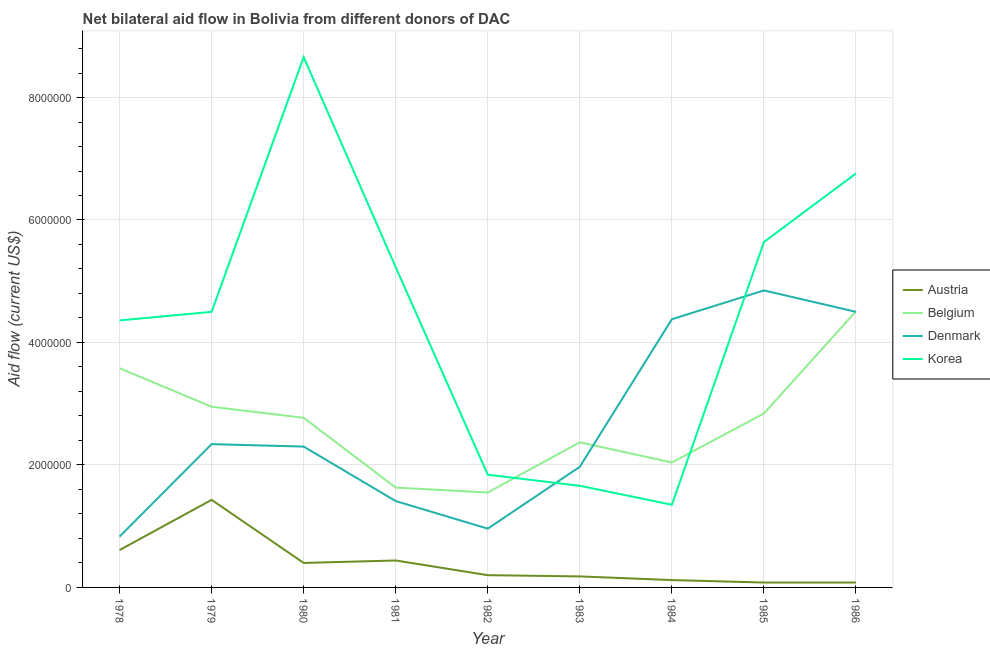Does the line corresponding to amount of aid given by austria intersect with the line corresponding to amount of aid given by korea?
Provide a succinct answer. No. What is the amount of aid given by austria in 1981?
Offer a very short reply. 4.40e+05. Across all years, what is the maximum amount of aid given by korea?
Give a very brief answer. 8.66e+06. Across all years, what is the minimum amount of aid given by austria?
Provide a succinct answer. 8.00e+04. In which year was the amount of aid given by belgium minimum?
Offer a terse response. 1982. What is the total amount of aid given by austria in the graph?
Your response must be concise. 3.54e+06. What is the difference between the amount of aid given by korea in 1979 and that in 1982?
Make the answer very short. 2.66e+06. What is the difference between the amount of aid given by austria in 1984 and the amount of aid given by denmark in 1986?
Provide a short and direct response. -4.38e+06. What is the average amount of aid given by denmark per year?
Make the answer very short. 2.62e+06. In the year 1983, what is the difference between the amount of aid given by denmark and amount of aid given by austria?
Give a very brief answer. 1.79e+06. What is the ratio of the amount of aid given by austria in 1980 to that in 1984?
Your answer should be compact. 3.33. Is the amount of aid given by denmark in 1980 less than that in 1982?
Offer a very short reply. No. Is the difference between the amount of aid given by belgium in 1979 and 1981 greater than the difference between the amount of aid given by austria in 1979 and 1981?
Provide a short and direct response. Yes. What is the difference between the highest and the second highest amount of aid given by korea?
Offer a terse response. 1.90e+06. What is the difference between the highest and the lowest amount of aid given by korea?
Provide a short and direct response. 7.31e+06. In how many years, is the amount of aid given by austria greater than the average amount of aid given by austria taken over all years?
Offer a very short reply. 4. Is the sum of the amount of aid given by belgium in 1983 and 1986 greater than the maximum amount of aid given by denmark across all years?
Your response must be concise. Yes. Is it the case that in every year, the sum of the amount of aid given by belgium and amount of aid given by austria is greater than the sum of amount of aid given by korea and amount of aid given by denmark?
Your response must be concise. No. Is it the case that in every year, the sum of the amount of aid given by austria and amount of aid given by belgium is greater than the amount of aid given by denmark?
Provide a short and direct response. No. Does the amount of aid given by belgium monotonically increase over the years?
Give a very brief answer. No. Is the amount of aid given by belgium strictly greater than the amount of aid given by denmark over the years?
Offer a terse response. No. How many lines are there?
Offer a terse response. 4. How many years are there in the graph?
Provide a short and direct response. 9. Does the graph contain any zero values?
Your answer should be very brief. No. Does the graph contain grids?
Your answer should be compact. Yes. How are the legend labels stacked?
Your answer should be compact. Vertical. What is the title of the graph?
Provide a short and direct response. Net bilateral aid flow in Bolivia from different donors of DAC. What is the label or title of the Y-axis?
Give a very brief answer. Aid flow (current US$). What is the Aid flow (current US$) in Austria in 1978?
Make the answer very short. 6.10e+05. What is the Aid flow (current US$) of Belgium in 1978?
Offer a very short reply. 3.58e+06. What is the Aid flow (current US$) in Denmark in 1978?
Keep it short and to the point. 8.30e+05. What is the Aid flow (current US$) of Korea in 1978?
Keep it short and to the point. 4.36e+06. What is the Aid flow (current US$) of Austria in 1979?
Your response must be concise. 1.43e+06. What is the Aid flow (current US$) in Belgium in 1979?
Provide a short and direct response. 2.95e+06. What is the Aid flow (current US$) in Denmark in 1979?
Your answer should be compact. 2.34e+06. What is the Aid flow (current US$) in Korea in 1979?
Give a very brief answer. 4.50e+06. What is the Aid flow (current US$) in Austria in 1980?
Your answer should be compact. 4.00e+05. What is the Aid flow (current US$) in Belgium in 1980?
Keep it short and to the point. 2.77e+06. What is the Aid flow (current US$) of Denmark in 1980?
Make the answer very short. 2.30e+06. What is the Aid flow (current US$) in Korea in 1980?
Ensure brevity in your answer.  8.66e+06. What is the Aid flow (current US$) in Austria in 1981?
Ensure brevity in your answer.  4.40e+05. What is the Aid flow (current US$) of Belgium in 1981?
Your answer should be compact. 1.63e+06. What is the Aid flow (current US$) in Denmark in 1981?
Give a very brief answer. 1.41e+06. What is the Aid flow (current US$) of Korea in 1981?
Provide a succinct answer. 5.23e+06. What is the Aid flow (current US$) in Austria in 1982?
Offer a very short reply. 2.00e+05. What is the Aid flow (current US$) in Belgium in 1982?
Ensure brevity in your answer.  1.55e+06. What is the Aid flow (current US$) of Denmark in 1982?
Your response must be concise. 9.60e+05. What is the Aid flow (current US$) in Korea in 1982?
Keep it short and to the point. 1.84e+06. What is the Aid flow (current US$) of Belgium in 1983?
Provide a succinct answer. 2.37e+06. What is the Aid flow (current US$) of Denmark in 1983?
Your answer should be compact. 1.97e+06. What is the Aid flow (current US$) of Korea in 1983?
Provide a short and direct response. 1.66e+06. What is the Aid flow (current US$) in Belgium in 1984?
Make the answer very short. 2.04e+06. What is the Aid flow (current US$) of Denmark in 1984?
Offer a very short reply. 4.38e+06. What is the Aid flow (current US$) of Korea in 1984?
Your response must be concise. 1.35e+06. What is the Aid flow (current US$) in Austria in 1985?
Give a very brief answer. 8.00e+04. What is the Aid flow (current US$) in Belgium in 1985?
Give a very brief answer. 2.84e+06. What is the Aid flow (current US$) of Denmark in 1985?
Your response must be concise. 4.85e+06. What is the Aid flow (current US$) in Korea in 1985?
Your answer should be very brief. 5.64e+06. What is the Aid flow (current US$) in Austria in 1986?
Ensure brevity in your answer.  8.00e+04. What is the Aid flow (current US$) of Belgium in 1986?
Offer a terse response. 4.51e+06. What is the Aid flow (current US$) of Denmark in 1986?
Make the answer very short. 4.50e+06. What is the Aid flow (current US$) in Korea in 1986?
Give a very brief answer. 6.76e+06. Across all years, what is the maximum Aid flow (current US$) of Austria?
Offer a very short reply. 1.43e+06. Across all years, what is the maximum Aid flow (current US$) in Belgium?
Give a very brief answer. 4.51e+06. Across all years, what is the maximum Aid flow (current US$) of Denmark?
Make the answer very short. 4.85e+06. Across all years, what is the maximum Aid flow (current US$) of Korea?
Provide a succinct answer. 8.66e+06. Across all years, what is the minimum Aid flow (current US$) of Austria?
Your answer should be compact. 8.00e+04. Across all years, what is the minimum Aid flow (current US$) of Belgium?
Provide a succinct answer. 1.55e+06. Across all years, what is the minimum Aid flow (current US$) in Denmark?
Provide a short and direct response. 8.30e+05. Across all years, what is the minimum Aid flow (current US$) of Korea?
Offer a very short reply. 1.35e+06. What is the total Aid flow (current US$) in Austria in the graph?
Give a very brief answer. 3.54e+06. What is the total Aid flow (current US$) of Belgium in the graph?
Offer a very short reply. 2.42e+07. What is the total Aid flow (current US$) of Denmark in the graph?
Your answer should be compact. 2.35e+07. What is the total Aid flow (current US$) in Korea in the graph?
Provide a succinct answer. 4.00e+07. What is the difference between the Aid flow (current US$) in Austria in 1978 and that in 1979?
Make the answer very short. -8.20e+05. What is the difference between the Aid flow (current US$) of Belgium in 1978 and that in 1979?
Your answer should be compact. 6.30e+05. What is the difference between the Aid flow (current US$) in Denmark in 1978 and that in 1979?
Give a very brief answer. -1.51e+06. What is the difference between the Aid flow (current US$) in Austria in 1978 and that in 1980?
Your response must be concise. 2.10e+05. What is the difference between the Aid flow (current US$) of Belgium in 1978 and that in 1980?
Give a very brief answer. 8.10e+05. What is the difference between the Aid flow (current US$) in Denmark in 1978 and that in 1980?
Offer a terse response. -1.47e+06. What is the difference between the Aid flow (current US$) of Korea in 1978 and that in 1980?
Offer a terse response. -4.30e+06. What is the difference between the Aid flow (current US$) of Austria in 1978 and that in 1981?
Make the answer very short. 1.70e+05. What is the difference between the Aid flow (current US$) in Belgium in 1978 and that in 1981?
Give a very brief answer. 1.95e+06. What is the difference between the Aid flow (current US$) in Denmark in 1978 and that in 1981?
Make the answer very short. -5.80e+05. What is the difference between the Aid flow (current US$) in Korea in 1978 and that in 1981?
Provide a succinct answer. -8.70e+05. What is the difference between the Aid flow (current US$) of Belgium in 1978 and that in 1982?
Provide a succinct answer. 2.03e+06. What is the difference between the Aid flow (current US$) in Denmark in 1978 and that in 1982?
Give a very brief answer. -1.30e+05. What is the difference between the Aid flow (current US$) in Korea in 1978 and that in 1982?
Ensure brevity in your answer.  2.52e+06. What is the difference between the Aid flow (current US$) of Belgium in 1978 and that in 1983?
Make the answer very short. 1.21e+06. What is the difference between the Aid flow (current US$) of Denmark in 1978 and that in 1983?
Keep it short and to the point. -1.14e+06. What is the difference between the Aid flow (current US$) of Korea in 1978 and that in 1983?
Provide a short and direct response. 2.70e+06. What is the difference between the Aid flow (current US$) in Austria in 1978 and that in 1984?
Provide a short and direct response. 4.90e+05. What is the difference between the Aid flow (current US$) of Belgium in 1978 and that in 1984?
Give a very brief answer. 1.54e+06. What is the difference between the Aid flow (current US$) in Denmark in 1978 and that in 1984?
Your answer should be very brief. -3.55e+06. What is the difference between the Aid flow (current US$) of Korea in 1978 and that in 1984?
Provide a short and direct response. 3.01e+06. What is the difference between the Aid flow (current US$) in Austria in 1978 and that in 1985?
Offer a terse response. 5.30e+05. What is the difference between the Aid flow (current US$) of Belgium in 1978 and that in 1985?
Keep it short and to the point. 7.40e+05. What is the difference between the Aid flow (current US$) of Denmark in 1978 and that in 1985?
Keep it short and to the point. -4.02e+06. What is the difference between the Aid flow (current US$) in Korea in 1978 and that in 1985?
Give a very brief answer. -1.28e+06. What is the difference between the Aid flow (current US$) of Austria in 1978 and that in 1986?
Offer a very short reply. 5.30e+05. What is the difference between the Aid flow (current US$) of Belgium in 1978 and that in 1986?
Provide a short and direct response. -9.30e+05. What is the difference between the Aid flow (current US$) of Denmark in 1978 and that in 1986?
Provide a short and direct response. -3.67e+06. What is the difference between the Aid flow (current US$) in Korea in 1978 and that in 1986?
Provide a succinct answer. -2.40e+06. What is the difference between the Aid flow (current US$) in Austria in 1979 and that in 1980?
Offer a very short reply. 1.03e+06. What is the difference between the Aid flow (current US$) in Belgium in 1979 and that in 1980?
Ensure brevity in your answer.  1.80e+05. What is the difference between the Aid flow (current US$) in Korea in 1979 and that in 1980?
Your answer should be very brief. -4.16e+06. What is the difference between the Aid flow (current US$) of Austria in 1979 and that in 1981?
Your answer should be very brief. 9.90e+05. What is the difference between the Aid flow (current US$) of Belgium in 1979 and that in 1981?
Give a very brief answer. 1.32e+06. What is the difference between the Aid flow (current US$) of Denmark in 1979 and that in 1981?
Ensure brevity in your answer.  9.30e+05. What is the difference between the Aid flow (current US$) of Korea in 1979 and that in 1981?
Ensure brevity in your answer.  -7.30e+05. What is the difference between the Aid flow (current US$) in Austria in 1979 and that in 1982?
Provide a succinct answer. 1.23e+06. What is the difference between the Aid flow (current US$) in Belgium in 1979 and that in 1982?
Give a very brief answer. 1.40e+06. What is the difference between the Aid flow (current US$) of Denmark in 1979 and that in 1982?
Keep it short and to the point. 1.38e+06. What is the difference between the Aid flow (current US$) of Korea in 1979 and that in 1982?
Your answer should be very brief. 2.66e+06. What is the difference between the Aid flow (current US$) in Austria in 1979 and that in 1983?
Provide a succinct answer. 1.25e+06. What is the difference between the Aid flow (current US$) of Belgium in 1979 and that in 1983?
Ensure brevity in your answer.  5.80e+05. What is the difference between the Aid flow (current US$) in Denmark in 1979 and that in 1983?
Provide a short and direct response. 3.70e+05. What is the difference between the Aid flow (current US$) in Korea in 1979 and that in 1983?
Your answer should be compact. 2.84e+06. What is the difference between the Aid flow (current US$) of Austria in 1979 and that in 1984?
Make the answer very short. 1.31e+06. What is the difference between the Aid flow (current US$) in Belgium in 1979 and that in 1984?
Your answer should be compact. 9.10e+05. What is the difference between the Aid flow (current US$) of Denmark in 1979 and that in 1984?
Provide a succinct answer. -2.04e+06. What is the difference between the Aid flow (current US$) in Korea in 1979 and that in 1984?
Your answer should be compact. 3.15e+06. What is the difference between the Aid flow (current US$) in Austria in 1979 and that in 1985?
Give a very brief answer. 1.35e+06. What is the difference between the Aid flow (current US$) of Denmark in 1979 and that in 1985?
Your response must be concise. -2.51e+06. What is the difference between the Aid flow (current US$) of Korea in 1979 and that in 1985?
Offer a terse response. -1.14e+06. What is the difference between the Aid flow (current US$) in Austria in 1979 and that in 1986?
Offer a terse response. 1.35e+06. What is the difference between the Aid flow (current US$) in Belgium in 1979 and that in 1986?
Offer a terse response. -1.56e+06. What is the difference between the Aid flow (current US$) in Denmark in 1979 and that in 1986?
Ensure brevity in your answer.  -2.16e+06. What is the difference between the Aid flow (current US$) of Korea in 1979 and that in 1986?
Keep it short and to the point. -2.26e+06. What is the difference between the Aid flow (current US$) of Austria in 1980 and that in 1981?
Your answer should be very brief. -4.00e+04. What is the difference between the Aid flow (current US$) in Belgium in 1980 and that in 1981?
Your response must be concise. 1.14e+06. What is the difference between the Aid flow (current US$) in Denmark in 1980 and that in 1981?
Ensure brevity in your answer.  8.90e+05. What is the difference between the Aid flow (current US$) in Korea in 1980 and that in 1981?
Your response must be concise. 3.43e+06. What is the difference between the Aid flow (current US$) of Belgium in 1980 and that in 1982?
Your response must be concise. 1.22e+06. What is the difference between the Aid flow (current US$) of Denmark in 1980 and that in 1982?
Give a very brief answer. 1.34e+06. What is the difference between the Aid flow (current US$) in Korea in 1980 and that in 1982?
Your response must be concise. 6.82e+06. What is the difference between the Aid flow (current US$) of Belgium in 1980 and that in 1983?
Offer a terse response. 4.00e+05. What is the difference between the Aid flow (current US$) in Austria in 1980 and that in 1984?
Ensure brevity in your answer.  2.80e+05. What is the difference between the Aid flow (current US$) of Belgium in 1980 and that in 1984?
Ensure brevity in your answer.  7.30e+05. What is the difference between the Aid flow (current US$) in Denmark in 1980 and that in 1984?
Keep it short and to the point. -2.08e+06. What is the difference between the Aid flow (current US$) of Korea in 1980 and that in 1984?
Provide a short and direct response. 7.31e+06. What is the difference between the Aid flow (current US$) of Denmark in 1980 and that in 1985?
Offer a terse response. -2.55e+06. What is the difference between the Aid flow (current US$) in Korea in 1980 and that in 1985?
Offer a very short reply. 3.02e+06. What is the difference between the Aid flow (current US$) of Austria in 1980 and that in 1986?
Give a very brief answer. 3.20e+05. What is the difference between the Aid flow (current US$) in Belgium in 1980 and that in 1986?
Offer a very short reply. -1.74e+06. What is the difference between the Aid flow (current US$) of Denmark in 1980 and that in 1986?
Your answer should be very brief. -2.20e+06. What is the difference between the Aid flow (current US$) in Korea in 1980 and that in 1986?
Your answer should be compact. 1.90e+06. What is the difference between the Aid flow (current US$) in Denmark in 1981 and that in 1982?
Give a very brief answer. 4.50e+05. What is the difference between the Aid flow (current US$) of Korea in 1981 and that in 1982?
Give a very brief answer. 3.39e+06. What is the difference between the Aid flow (current US$) of Austria in 1981 and that in 1983?
Keep it short and to the point. 2.60e+05. What is the difference between the Aid flow (current US$) in Belgium in 1981 and that in 1983?
Make the answer very short. -7.40e+05. What is the difference between the Aid flow (current US$) of Denmark in 1981 and that in 1983?
Your answer should be very brief. -5.60e+05. What is the difference between the Aid flow (current US$) in Korea in 1981 and that in 1983?
Make the answer very short. 3.57e+06. What is the difference between the Aid flow (current US$) in Belgium in 1981 and that in 1984?
Your response must be concise. -4.10e+05. What is the difference between the Aid flow (current US$) in Denmark in 1981 and that in 1984?
Give a very brief answer. -2.97e+06. What is the difference between the Aid flow (current US$) of Korea in 1981 and that in 1984?
Provide a short and direct response. 3.88e+06. What is the difference between the Aid flow (current US$) in Belgium in 1981 and that in 1985?
Offer a terse response. -1.21e+06. What is the difference between the Aid flow (current US$) of Denmark in 1981 and that in 1985?
Your response must be concise. -3.44e+06. What is the difference between the Aid flow (current US$) in Korea in 1981 and that in 1985?
Give a very brief answer. -4.10e+05. What is the difference between the Aid flow (current US$) in Belgium in 1981 and that in 1986?
Your answer should be very brief. -2.88e+06. What is the difference between the Aid flow (current US$) in Denmark in 1981 and that in 1986?
Ensure brevity in your answer.  -3.09e+06. What is the difference between the Aid flow (current US$) in Korea in 1981 and that in 1986?
Offer a very short reply. -1.53e+06. What is the difference between the Aid flow (current US$) of Belgium in 1982 and that in 1983?
Provide a short and direct response. -8.20e+05. What is the difference between the Aid flow (current US$) in Denmark in 1982 and that in 1983?
Provide a succinct answer. -1.01e+06. What is the difference between the Aid flow (current US$) in Korea in 1982 and that in 1983?
Ensure brevity in your answer.  1.80e+05. What is the difference between the Aid flow (current US$) in Belgium in 1982 and that in 1984?
Provide a short and direct response. -4.90e+05. What is the difference between the Aid flow (current US$) in Denmark in 1982 and that in 1984?
Ensure brevity in your answer.  -3.42e+06. What is the difference between the Aid flow (current US$) of Belgium in 1982 and that in 1985?
Give a very brief answer. -1.29e+06. What is the difference between the Aid flow (current US$) of Denmark in 1982 and that in 1985?
Ensure brevity in your answer.  -3.89e+06. What is the difference between the Aid flow (current US$) in Korea in 1982 and that in 1985?
Your answer should be very brief. -3.80e+06. What is the difference between the Aid flow (current US$) in Austria in 1982 and that in 1986?
Give a very brief answer. 1.20e+05. What is the difference between the Aid flow (current US$) of Belgium in 1982 and that in 1986?
Your answer should be compact. -2.96e+06. What is the difference between the Aid flow (current US$) of Denmark in 1982 and that in 1986?
Keep it short and to the point. -3.54e+06. What is the difference between the Aid flow (current US$) in Korea in 1982 and that in 1986?
Ensure brevity in your answer.  -4.92e+06. What is the difference between the Aid flow (current US$) in Austria in 1983 and that in 1984?
Give a very brief answer. 6.00e+04. What is the difference between the Aid flow (current US$) of Denmark in 1983 and that in 1984?
Offer a very short reply. -2.41e+06. What is the difference between the Aid flow (current US$) in Korea in 1983 and that in 1984?
Keep it short and to the point. 3.10e+05. What is the difference between the Aid flow (current US$) of Austria in 1983 and that in 1985?
Give a very brief answer. 1.00e+05. What is the difference between the Aid flow (current US$) in Belgium in 1983 and that in 1985?
Provide a succinct answer. -4.70e+05. What is the difference between the Aid flow (current US$) in Denmark in 1983 and that in 1985?
Your answer should be very brief. -2.88e+06. What is the difference between the Aid flow (current US$) in Korea in 1983 and that in 1985?
Your answer should be very brief. -3.98e+06. What is the difference between the Aid flow (current US$) of Austria in 1983 and that in 1986?
Provide a succinct answer. 1.00e+05. What is the difference between the Aid flow (current US$) of Belgium in 1983 and that in 1986?
Make the answer very short. -2.14e+06. What is the difference between the Aid flow (current US$) in Denmark in 1983 and that in 1986?
Provide a succinct answer. -2.53e+06. What is the difference between the Aid flow (current US$) in Korea in 1983 and that in 1986?
Your answer should be very brief. -5.10e+06. What is the difference between the Aid flow (current US$) of Belgium in 1984 and that in 1985?
Keep it short and to the point. -8.00e+05. What is the difference between the Aid flow (current US$) in Denmark in 1984 and that in 1985?
Your answer should be very brief. -4.70e+05. What is the difference between the Aid flow (current US$) of Korea in 1984 and that in 1985?
Provide a short and direct response. -4.29e+06. What is the difference between the Aid flow (current US$) of Austria in 1984 and that in 1986?
Make the answer very short. 4.00e+04. What is the difference between the Aid flow (current US$) in Belgium in 1984 and that in 1986?
Offer a very short reply. -2.47e+06. What is the difference between the Aid flow (current US$) of Denmark in 1984 and that in 1986?
Ensure brevity in your answer.  -1.20e+05. What is the difference between the Aid flow (current US$) in Korea in 1984 and that in 1986?
Offer a terse response. -5.41e+06. What is the difference between the Aid flow (current US$) of Belgium in 1985 and that in 1986?
Keep it short and to the point. -1.67e+06. What is the difference between the Aid flow (current US$) in Denmark in 1985 and that in 1986?
Keep it short and to the point. 3.50e+05. What is the difference between the Aid flow (current US$) of Korea in 1985 and that in 1986?
Provide a short and direct response. -1.12e+06. What is the difference between the Aid flow (current US$) of Austria in 1978 and the Aid flow (current US$) of Belgium in 1979?
Ensure brevity in your answer.  -2.34e+06. What is the difference between the Aid flow (current US$) of Austria in 1978 and the Aid flow (current US$) of Denmark in 1979?
Keep it short and to the point. -1.73e+06. What is the difference between the Aid flow (current US$) in Austria in 1978 and the Aid flow (current US$) in Korea in 1979?
Provide a short and direct response. -3.89e+06. What is the difference between the Aid flow (current US$) in Belgium in 1978 and the Aid flow (current US$) in Denmark in 1979?
Your answer should be very brief. 1.24e+06. What is the difference between the Aid flow (current US$) in Belgium in 1978 and the Aid flow (current US$) in Korea in 1979?
Your answer should be compact. -9.20e+05. What is the difference between the Aid flow (current US$) in Denmark in 1978 and the Aid flow (current US$) in Korea in 1979?
Ensure brevity in your answer.  -3.67e+06. What is the difference between the Aid flow (current US$) of Austria in 1978 and the Aid flow (current US$) of Belgium in 1980?
Provide a succinct answer. -2.16e+06. What is the difference between the Aid flow (current US$) of Austria in 1978 and the Aid flow (current US$) of Denmark in 1980?
Your response must be concise. -1.69e+06. What is the difference between the Aid flow (current US$) of Austria in 1978 and the Aid flow (current US$) of Korea in 1980?
Ensure brevity in your answer.  -8.05e+06. What is the difference between the Aid flow (current US$) in Belgium in 1978 and the Aid flow (current US$) in Denmark in 1980?
Provide a short and direct response. 1.28e+06. What is the difference between the Aid flow (current US$) of Belgium in 1978 and the Aid flow (current US$) of Korea in 1980?
Keep it short and to the point. -5.08e+06. What is the difference between the Aid flow (current US$) in Denmark in 1978 and the Aid flow (current US$) in Korea in 1980?
Make the answer very short. -7.83e+06. What is the difference between the Aid flow (current US$) in Austria in 1978 and the Aid flow (current US$) in Belgium in 1981?
Your answer should be compact. -1.02e+06. What is the difference between the Aid flow (current US$) in Austria in 1978 and the Aid flow (current US$) in Denmark in 1981?
Your answer should be very brief. -8.00e+05. What is the difference between the Aid flow (current US$) in Austria in 1978 and the Aid flow (current US$) in Korea in 1981?
Provide a succinct answer. -4.62e+06. What is the difference between the Aid flow (current US$) in Belgium in 1978 and the Aid flow (current US$) in Denmark in 1981?
Offer a terse response. 2.17e+06. What is the difference between the Aid flow (current US$) in Belgium in 1978 and the Aid flow (current US$) in Korea in 1981?
Make the answer very short. -1.65e+06. What is the difference between the Aid flow (current US$) of Denmark in 1978 and the Aid flow (current US$) of Korea in 1981?
Your answer should be compact. -4.40e+06. What is the difference between the Aid flow (current US$) of Austria in 1978 and the Aid flow (current US$) of Belgium in 1982?
Keep it short and to the point. -9.40e+05. What is the difference between the Aid flow (current US$) of Austria in 1978 and the Aid flow (current US$) of Denmark in 1982?
Ensure brevity in your answer.  -3.50e+05. What is the difference between the Aid flow (current US$) of Austria in 1978 and the Aid flow (current US$) of Korea in 1982?
Provide a succinct answer. -1.23e+06. What is the difference between the Aid flow (current US$) in Belgium in 1978 and the Aid flow (current US$) in Denmark in 1982?
Ensure brevity in your answer.  2.62e+06. What is the difference between the Aid flow (current US$) of Belgium in 1978 and the Aid flow (current US$) of Korea in 1982?
Give a very brief answer. 1.74e+06. What is the difference between the Aid flow (current US$) in Denmark in 1978 and the Aid flow (current US$) in Korea in 1982?
Give a very brief answer. -1.01e+06. What is the difference between the Aid flow (current US$) in Austria in 1978 and the Aid flow (current US$) in Belgium in 1983?
Provide a short and direct response. -1.76e+06. What is the difference between the Aid flow (current US$) of Austria in 1978 and the Aid flow (current US$) of Denmark in 1983?
Ensure brevity in your answer.  -1.36e+06. What is the difference between the Aid flow (current US$) in Austria in 1978 and the Aid flow (current US$) in Korea in 1983?
Your response must be concise. -1.05e+06. What is the difference between the Aid flow (current US$) of Belgium in 1978 and the Aid flow (current US$) of Denmark in 1983?
Keep it short and to the point. 1.61e+06. What is the difference between the Aid flow (current US$) of Belgium in 1978 and the Aid flow (current US$) of Korea in 1983?
Ensure brevity in your answer.  1.92e+06. What is the difference between the Aid flow (current US$) of Denmark in 1978 and the Aid flow (current US$) of Korea in 1983?
Give a very brief answer. -8.30e+05. What is the difference between the Aid flow (current US$) of Austria in 1978 and the Aid flow (current US$) of Belgium in 1984?
Provide a succinct answer. -1.43e+06. What is the difference between the Aid flow (current US$) of Austria in 1978 and the Aid flow (current US$) of Denmark in 1984?
Give a very brief answer. -3.77e+06. What is the difference between the Aid flow (current US$) in Austria in 1978 and the Aid flow (current US$) in Korea in 1984?
Keep it short and to the point. -7.40e+05. What is the difference between the Aid flow (current US$) in Belgium in 1978 and the Aid flow (current US$) in Denmark in 1984?
Provide a short and direct response. -8.00e+05. What is the difference between the Aid flow (current US$) in Belgium in 1978 and the Aid flow (current US$) in Korea in 1984?
Your response must be concise. 2.23e+06. What is the difference between the Aid flow (current US$) of Denmark in 1978 and the Aid flow (current US$) of Korea in 1984?
Give a very brief answer. -5.20e+05. What is the difference between the Aid flow (current US$) in Austria in 1978 and the Aid flow (current US$) in Belgium in 1985?
Keep it short and to the point. -2.23e+06. What is the difference between the Aid flow (current US$) in Austria in 1978 and the Aid flow (current US$) in Denmark in 1985?
Ensure brevity in your answer.  -4.24e+06. What is the difference between the Aid flow (current US$) in Austria in 1978 and the Aid flow (current US$) in Korea in 1985?
Make the answer very short. -5.03e+06. What is the difference between the Aid flow (current US$) in Belgium in 1978 and the Aid flow (current US$) in Denmark in 1985?
Provide a succinct answer. -1.27e+06. What is the difference between the Aid flow (current US$) of Belgium in 1978 and the Aid flow (current US$) of Korea in 1985?
Offer a terse response. -2.06e+06. What is the difference between the Aid flow (current US$) of Denmark in 1978 and the Aid flow (current US$) of Korea in 1985?
Your answer should be compact. -4.81e+06. What is the difference between the Aid flow (current US$) in Austria in 1978 and the Aid flow (current US$) in Belgium in 1986?
Keep it short and to the point. -3.90e+06. What is the difference between the Aid flow (current US$) of Austria in 1978 and the Aid flow (current US$) of Denmark in 1986?
Give a very brief answer. -3.89e+06. What is the difference between the Aid flow (current US$) in Austria in 1978 and the Aid flow (current US$) in Korea in 1986?
Ensure brevity in your answer.  -6.15e+06. What is the difference between the Aid flow (current US$) in Belgium in 1978 and the Aid flow (current US$) in Denmark in 1986?
Give a very brief answer. -9.20e+05. What is the difference between the Aid flow (current US$) in Belgium in 1978 and the Aid flow (current US$) in Korea in 1986?
Keep it short and to the point. -3.18e+06. What is the difference between the Aid flow (current US$) in Denmark in 1978 and the Aid flow (current US$) in Korea in 1986?
Give a very brief answer. -5.93e+06. What is the difference between the Aid flow (current US$) of Austria in 1979 and the Aid flow (current US$) of Belgium in 1980?
Provide a short and direct response. -1.34e+06. What is the difference between the Aid flow (current US$) in Austria in 1979 and the Aid flow (current US$) in Denmark in 1980?
Your answer should be compact. -8.70e+05. What is the difference between the Aid flow (current US$) of Austria in 1979 and the Aid flow (current US$) of Korea in 1980?
Provide a short and direct response. -7.23e+06. What is the difference between the Aid flow (current US$) in Belgium in 1979 and the Aid flow (current US$) in Denmark in 1980?
Provide a short and direct response. 6.50e+05. What is the difference between the Aid flow (current US$) of Belgium in 1979 and the Aid flow (current US$) of Korea in 1980?
Give a very brief answer. -5.71e+06. What is the difference between the Aid flow (current US$) in Denmark in 1979 and the Aid flow (current US$) in Korea in 1980?
Your answer should be very brief. -6.32e+06. What is the difference between the Aid flow (current US$) of Austria in 1979 and the Aid flow (current US$) of Korea in 1981?
Your response must be concise. -3.80e+06. What is the difference between the Aid flow (current US$) of Belgium in 1979 and the Aid flow (current US$) of Denmark in 1981?
Make the answer very short. 1.54e+06. What is the difference between the Aid flow (current US$) in Belgium in 1979 and the Aid flow (current US$) in Korea in 1981?
Give a very brief answer. -2.28e+06. What is the difference between the Aid flow (current US$) of Denmark in 1979 and the Aid flow (current US$) of Korea in 1981?
Make the answer very short. -2.89e+06. What is the difference between the Aid flow (current US$) in Austria in 1979 and the Aid flow (current US$) in Belgium in 1982?
Your answer should be compact. -1.20e+05. What is the difference between the Aid flow (current US$) of Austria in 1979 and the Aid flow (current US$) of Denmark in 1982?
Make the answer very short. 4.70e+05. What is the difference between the Aid flow (current US$) in Austria in 1979 and the Aid flow (current US$) in Korea in 1982?
Your answer should be very brief. -4.10e+05. What is the difference between the Aid flow (current US$) in Belgium in 1979 and the Aid flow (current US$) in Denmark in 1982?
Give a very brief answer. 1.99e+06. What is the difference between the Aid flow (current US$) of Belgium in 1979 and the Aid flow (current US$) of Korea in 1982?
Provide a succinct answer. 1.11e+06. What is the difference between the Aid flow (current US$) of Denmark in 1979 and the Aid flow (current US$) of Korea in 1982?
Offer a terse response. 5.00e+05. What is the difference between the Aid flow (current US$) in Austria in 1979 and the Aid flow (current US$) in Belgium in 1983?
Give a very brief answer. -9.40e+05. What is the difference between the Aid flow (current US$) of Austria in 1979 and the Aid flow (current US$) of Denmark in 1983?
Ensure brevity in your answer.  -5.40e+05. What is the difference between the Aid flow (current US$) of Belgium in 1979 and the Aid flow (current US$) of Denmark in 1983?
Provide a short and direct response. 9.80e+05. What is the difference between the Aid flow (current US$) in Belgium in 1979 and the Aid flow (current US$) in Korea in 1983?
Provide a short and direct response. 1.29e+06. What is the difference between the Aid flow (current US$) of Denmark in 1979 and the Aid flow (current US$) of Korea in 1983?
Offer a terse response. 6.80e+05. What is the difference between the Aid flow (current US$) of Austria in 1979 and the Aid flow (current US$) of Belgium in 1984?
Your answer should be very brief. -6.10e+05. What is the difference between the Aid flow (current US$) in Austria in 1979 and the Aid flow (current US$) in Denmark in 1984?
Offer a very short reply. -2.95e+06. What is the difference between the Aid flow (current US$) in Belgium in 1979 and the Aid flow (current US$) in Denmark in 1984?
Make the answer very short. -1.43e+06. What is the difference between the Aid flow (current US$) in Belgium in 1979 and the Aid flow (current US$) in Korea in 1984?
Provide a short and direct response. 1.60e+06. What is the difference between the Aid flow (current US$) in Denmark in 1979 and the Aid flow (current US$) in Korea in 1984?
Provide a succinct answer. 9.90e+05. What is the difference between the Aid flow (current US$) of Austria in 1979 and the Aid flow (current US$) of Belgium in 1985?
Your response must be concise. -1.41e+06. What is the difference between the Aid flow (current US$) of Austria in 1979 and the Aid flow (current US$) of Denmark in 1985?
Your response must be concise. -3.42e+06. What is the difference between the Aid flow (current US$) of Austria in 1979 and the Aid flow (current US$) of Korea in 1985?
Ensure brevity in your answer.  -4.21e+06. What is the difference between the Aid flow (current US$) in Belgium in 1979 and the Aid flow (current US$) in Denmark in 1985?
Give a very brief answer. -1.90e+06. What is the difference between the Aid flow (current US$) of Belgium in 1979 and the Aid flow (current US$) of Korea in 1985?
Provide a succinct answer. -2.69e+06. What is the difference between the Aid flow (current US$) in Denmark in 1979 and the Aid flow (current US$) in Korea in 1985?
Offer a very short reply. -3.30e+06. What is the difference between the Aid flow (current US$) of Austria in 1979 and the Aid flow (current US$) of Belgium in 1986?
Your answer should be compact. -3.08e+06. What is the difference between the Aid flow (current US$) of Austria in 1979 and the Aid flow (current US$) of Denmark in 1986?
Offer a terse response. -3.07e+06. What is the difference between the Aid flow (current US$) of Austria in 1979 and the Aid flow (current US$) of Korea in 1986?
Provide a short and direct response. -5.33e+06. What is the difference between the Aid flow (current US$) of Belgium in 1979 and the Aid flow (current US$) of Denmark in 1986?
Offer a terse response. -1.55e+06. What is the difference between the Aid flow (current US$) of Belgium in 1979 and the Aid flow (current US$) of Korea in 1986?
Give a very brief answer. -3.81e+06. What is the difference between the Aid flow (current US$) of Denmark in 1979 and the Aid flow (current US$) of Korea in 1986?
Provide a succinct answer. -4.42e+06. What is the difference between the Aid flow (current US$) in Austria in 1980 and the Aid flow (current US$) in Belgium in 1981?
Offer a terse response. -1.23e+06. What is the difference between the Aid flow (current US$) of Austria in 1980 and the Aid flow (current US$) of Denmark in 1981?
Your answer should be very brief. -1.01e+06. What is the difference between the Aid flow (current US$) in Austria in 1980 and the Aid flow (current US$) in Korea in 1981?
Your response must be concise. -4.83e+06. What is the difference between the Aid flow (current US$) of Belgium in 1980 and the Aid flow (current US$) of Denmark in 1981?
Provide a succinct answer. 1.36e+06. What is the difference between the Aid flow (current US$) of Belgium in 1980 and the Aid flow (current US$) of Korea in 1981?
Provide a short and direct response. -2.46e+06. What is the difference between the Aid flow (current US$) of Denmark in 1980 and the Aid flow (current US$) of Korea in 1981?
Your response must be concise. -2.93e+06. What is the difference between the Aid flow (current US$) of Austria in 1980 and the Aid flow (current US$) of Belgium in 1982?
Ensure brevity in your answer.  -1.15e+06. What is the difference between the Aid flow (current US$) in Austria in 1980 and the Aid flow (current US$) in Denmark in 1982?
Your response must be concise. -5.60e+05. What is the difference between the Aid flow (current US$) in Austria in 1980 and the Aid flow (current US$) in Korea in 1982?
Ensure brevity in your answer.  -1.44e+06. What is the difference between the Aid flow (current US$) in Belgium in 1980 and the Aid flow (current US$) in Denmark in 1982?
Your answer should be very brief. 1.81e+06. What is the difference between the Aid flow (current US$) of Belgium in 1980 and the Aid flow (current US$) of Korea in 1982?
Provide a succinct answer. 9.30e+05. What is the difference between the Aid flow (current US$) of Denmark in 1980 and the Aid flow (current US$) of Korea in 1982?
Offer a terse response. 4.60e+05. What is the difference between the Aid flow (current US$) in Austria in 1980 and the Aid flow (current US$) in Belgium in 1983?
Provide a short and direct response. -1.97e+06. What is the difference between the Aid flow (current US$) in Austria in 1980 and the Aid flow (current US$) in Denmark in 1983?
Provide a succinct answer. -1.57e+06. What is the difference between the Aid flow (current US$) in Austria in 1980 and the Aid flow (current US$) in Korea in 1983?
Provide a short and direct response. -1.26e+06. What is the difference between the Aid flow (current US$) of Belgium in 1980 and the Aid flow (current US$) of Korea in 1983?
Ensure brevity in your answer.  1.11e+06. What is the difference between the Aid flow (current US$) in Denmark in 1980 and the Aid flow (current US$) in Korea in 1983?
Ensure brevity in your answer.  6.40e+05. What is the difference between the Aid flow (current US$) in Austria in 1980 and the Aid flow (current US$) in Belgium in 1984?
Your response must be concise. -1.64e+06. What is the difference between the Aid flow (current US$) in Austria in 1980 and the Aid flow (current US$) in Denmark in 1984?
Offer a very short reply. -3.98e+06. What is the difference between the Aid flow (current US$) of Austria in 1980 and the Aid flow (current US$) of Korea in 1984?
Provide a short and direct response. -9.50e+05. What is the difference between the Aid flow (current US$) in Belgium in 1980 and the Aid flow (current US$) in Denmark in 1984?
Provide a short and direct response. -1.61e+06. What is the difference between the Aid flow (current US$) in Belgium in 1980 and the Aid flow (current US$) in Korea in 1984?
Make the answer very short. 1.42e+06. What is the difference between the Aid flow (current US$) of Denmark in 1980 and the Aid flow (current US$) of Korea in 1984?
Your answer should be compact. 9.50e+05. What is the difference between the Aid flow (current US$) in Austria in 1980 and the Aid flow (current US$) in Belgium in 1985?
Provide a succinct answer. -2.44e+06. What is the difference between the Aid flow (current US$) in Austria in 1980 and the Aid flow (current US$) in Denmark in 1985?
Your answer should be compact. -4.45e+06. What is the difference between the Aid flow (current US$) of Austria in 1980 and the Aid flow (current US$) of Korea in 1985?
Your answer should be compact. -5.24e+06. What is the difference between the Aid flow (current US$) in Belgium in 1980 and the Aid flow (current US$) in Denmark in 1985?
Your response must be concise. -2.08e+06. What is the difference between the Aid flow (current US$) in Belgium in 1980 and the Aid flow (current US$) in Korea in 1985?
Your answer should be very brief. -2.87e+06. What is the difference between the Aid flow (current US$) of Denmark in 1980 and the Aid flow (current US$) of Korea in 1985?
Keep it short and to the point. -3.34e+06. What is the difference between the Aid flow (current US$) in Austria in 1980 and the Aid flow (current US$) in Belgium in 1986?
Keep it short and to the point. -4.11e+06. What is the difference between the Aid flow (current US$) of Austria in 1980 and the Aid flow (current US$) of Denmark in 1986?
Give a very brief answer. -4.10e+06. What is the difference between the Aid flow (current US$) of Austria in 1980 and the Aid flow (current US$) of Korea in 1986?
Your answer should be compact. -6.36e+06. What is the difference between the Aid flow (current US$) in Belgium in 1980 and the Aid flow (current US$) in Denmark in 1986?
Offer a terse response. -1.73e+06. What is the difference between the Aid flow (current US$) in Belgium in 1980 and the Aid flow (current US$) in Korea in 1986?
Your answer should be very brief. -3.99e+06. What is the difference between the Aid flow (current US$) in Denmark in 1980 and the Aid flow (current US$) in Korea in 1986?
Your answer should be compact. -4.46e+06. What is the difference between the Aid flow (current US$) of Austria in 1981 and the Aid flow (current US$) of Belgium in 1982?
Provide a short and direct response. -1.11e+06. What is the difference between the Aid flow (current US$) of Austria in 1981 and the Aid flow (current US$) of Denmark in 1982?
Provide a succinct answer. -5.20e+05. What is the difference between the Aid flow (current US$) in Austria in 1981 and the Aid flow (current US$) in Korea in 1982?
Provide a short and direct response. -1.40e+06. What is the difference between the Aid flow (current US$) of Belgium in 1981 and the Aid flow (current US$) of Denmark in 1982?
Offer a very short reply. 6.70e+05. What is the difference between the Aid flow (current US$) in Belgium in 1981 and the Aid flow (current US$) in Korea in 1982?
Ensure brevity in your answer.  -2.10e+05. What is the difference between the Aid flow (current US$) in Denmark in 1981 and the Aid flow (current US$) in Korea in 1982?
Offer a very short reply. -4.30e+05. What is the difference between the Aid flow (current US$) of Austria in 1981 and the Aid flow (current US$) of Belgium in 1983?
Offer a terse response. -1.93e+06. What is the difference between the Aid flow (current US$) of Austria in 1981 and the Aid flow (current US$) of Denmark in 1983?
Ensure brevity in your answer.  -1.53e+06. What is the difference between the Aid flow (current US$) of Austria in 1981 and the Aid flow (current US$) of Korea in 1983?
Give a very brief answer. -1.22e+06. What is the difference between the Aid flow (current US$) of Belgium in 1981 and the Aid flow (current US$) of Denmark in 1983?
Provide a succinct answer. -3.40e+05. What is the difference between the Aid flow (current US$) in Belgium in 1981 and the Aid flow (current US$) in Korea in 1983?
Make the answer very short. -3.00e+04. What is the difference between the Aid flow (current US$) of Denmark in 1981 and the Aid flow (current US$) of Korea in 1983?
Keep it short and to the point. -2.50e+05. What is the difference between the Aid flow (current US$) in Austria in 1981 and the Aid flow (current US$) in Belgium in 1984?
Keep it short and to the point. -1.60e+06. What is the difference between the Aid flow (current US$) in Austria in 1981 and the Aid flow (current US$) in Denmark in 1984?
Your response must be concise. -3.94e+06. What is the difference between the Aid flow (current US$) of Austria in 1981 and the Aid flow (current US$) of Korea in 1984?
Ensure brevity in your answer.  -9.10e+05. What is the difference between the Aid flow (current US$) of Belgium in 1981 and the Aid flow (current US$) of Denmark in 1984?
Your answer should be very brief. -2.75e+06. What is the difference between the Aid flow (current US$) of Denmark in 1981 and the Aid flow (current US$) of Korea in 1984?
Provide a succinct answer. 6.00e+04. What is the difference between the Aid flow (current US$) in Austria in 1981 and the Aid flow (current US$) in Belgium in 1985?
Offer a very short reply. -2.40e+06. What is the difference between the Aid flow (current US$) of Austria in 1981 and the Aid flow (current US$) of Denmark in 1985?
Provide a short and direct response. -4.41e+06. What is the difference between the Aid flow (current US$) in Austria in 1981 and the Aid flow (current US$) in Korea in 1985?
Give a very brief answer. -5.20e+06. What is the difference between the Aid flow (current US$) in Belgium in 1981 and the Aid flow (current US$) in Denmark in 1985?
Provide a short and direct response. -3.22e+06. What is the difference between the Aid flow (current US$) of Belgium in 1981 and the Aid flow (current US$) of Korea in 1985?
Make the answer very short. -4.01e+06. What is the difference between the Aid flow (current US$) of Denmark in 1981 and the Aid flow (current US$) of Korea in 1985?
Your answer should be compact. -4.23e+06. What is the difference between the Aid flow (current US$) in Austria in 1981 and the Aid flow (current US$) in Belgium in 1986?
Your answer should be very brief. -4.07e+06. What is the difference between the Aid flow (current US$) of Austria in 1981 and the Aid flow (current US$) of Denmark in 1986?
Your answer should be compact. -4.06e+06. What is the difference between the Aid flow (current US$) in Austria in 1981 and the Aid flow (current US$) in Korea in 1986?
Provide a succinct answer. -6.32e+06. What is the difference between the Aid flow (current US$) in Belgium in 1981 and the Aid flow (current US$) in Denmark in 1986?
Provide a short and direct response. -2.87e+06. What is the difference between the Aid flow (current US$) in Belgium in 1981 and the Aid flow (current US$) in Korea in 1986?
Your response must be concise. -5.13e+06. What is the difference between the Aid flow (current US$) of Denmark in 1981 and the Aid flow (current US$) of Korea in 1986?
Provide a succinct answer. -5.35e+06. What is the difference between the Aid flow (current US$) of Austria in 1982 and the Aid flow (current US$) of Belgium in 1983?
Your answer should be very brief. -2.17e+06. What is the difference between the Aid flow (current US$) in Austria in 1982 and the Aid flow (current US$) in Denmark in 1983?
Offer a terse response. -1.77e+06. What is the difference between the Aid flow (current US$) in Austria in 1982 and the Aid flow (current US$) in Korea in 1983?
Make the answer very short. -1.46e+06. What is the difference between the Aid flow (current US$) in Belgium in 1982 and the Aid flow (current US$) in Denmark in 1983?
Ensure brevity in your answer.  -4.20e+05. What is the difference between the Aid flow (current US$) of Denmark in 1982 and the Aid flow (current US$) of Korea in 1983?
Keep it short and to the point. -7.00e+05. What is the difference between the Aid flow (current US$) of Austria in 1982 and the Aid flow (current US$) of Belgium in 1984?
Give a very brief answer. -1.84e+06. What is the difference between the Aid flow (current US$) of Austria in 1982 and the Aid flow (current US$) of Denmark in 1984?
Offer a very short reply. -4.18e+06. What is the difference between the Aid flow (current US$) in Austria in 1982 and the Aid flow (current US$) in Korea in 1984?
Your answer should be compact. -1.15e+06. What is the difference between the Aid flow (current US$) in Belgium in 1982 and the Aid flow (current US$) in Denmark in 1984?
Ensure brevity in your answer.  -2.83e+06. What is the difference between the Aid flow (current US$) of Denmark in 1982 and the Aid flow (current US$) of Korea in 1984?
Offer a terse response. -3.90e+05. What is the difference between the Aid flow (current US$) in Austria in 1982 and the Aid flow (current US$) in Belgium in 1985?
Keep it short and to the point. -2.64e+06. What is the difference between the Aid flow (current US$) of Austria in 1982 and the Aid flow (current US$) of Denmark in 1985?
Provide a short and direct response. -4.65e+06. What is the difference between the Aid flow (current US$) of Austria in 1982 and the Aid flow (current US$) of Korea in 1985?
Provide a short and direct response. -5.44e+06. What is the difference between the Aid flow (current US$) in Belgium in 1982 and the Aid flow (current US$) in Denmark in 1985?
Your answer should be very brief. -3.30e+06. What is the difference between the Aid flow (current US$) in Belgium in 1982 and the Aid flow (current US$) in Korea in 1985?
Keep it short and to the point. -4.09e+06. What is the difference between the Aid flow (current US$) of Denmark in 1982 and the Aid flow (current US$) of Korea in 1985?
Offer a very short reply. -4.68e+06. What is the difference between the Aid flow (current US$) in Austria in 1982 and the Aid flow (current US$) in Belgium in 1986?
Provide a short and direct response. -4.31e+06. What is the difference between the Aid flow (current US$) of Austria in 1982 and the Aid flow (current US$) of Denmark in 1986?
Offer a very short reply. -4.30e+06. What is the difference between the Aid flow (current US$) of Austria in 1982 and the Aid flow (current US$) of Korea in 1986?
Your answer should be compact. -6.56e+06. What is the difference between the Aid flow (current US$) in Belgium in 1982 and the Aid flow (current US$) in Denmark in 1986?
Offer a terse response. -2.95e+06. What is the difference between the Aid flow (current US$) in Belgium in 1982 and the Aid flow (current US$) in Korea in 1986?
Keep it short and to the point. -5.21e+06. What is the difference between the Aid flow (current US$) of Denmark in 1982 and the Aid flow (current US$) of Korea in 1986?
Ensure brevity in your answer.  -5.80e+06. What is the difference between the Aid flow (current US$) in Austria in 1983 and the Aid flow (current US$) in Belgium in 1984?
Offer a terse response. -1.86e+06. What is the difference between the Aid flow (current US$) of Austria in 1983 and the Aid flow (current US$) of Denmark in 1984?
Offer a very short reply. -4.20e+06. What is the difference between the Aid flow (current US$) in Austria in 1983 and the Aid flow (current US$) in Korea in 1984?
Offer a terse response. -1.17e+06. What is the difference between the Aid flow (current US$) in Belgium in 1983 and the Aid flow (current US$) in Denmark in 1984?
Keep it short and to the point. -2.01e+06. What is the difference between the Aid flow (current US$) in Belgium in 1983 and the Aid flow (current US$) in Korea in 1984?
Provide a short and direct response. 1.02e+06. What is the difference between the Aid flow (current US$) in Denmark in 1983 and the Aid flow (current US$) in Korea in 1984?
Keep it short and to the point. 6.20e+05. What is the difference between the Aid flow (current US$) in Austria in 1983 and the Aid flow (current US$) in Belgium in 1985?
Your response must be concise. -2.66e+06. What is the difference between the Aid flow (current US$) in Austria in 1983 and the Aid flow (current US$) in Denmark in 1985?
Give a very brief answer. -4.67e+06. What is the difference between the Aid flow (current US$) in Austria in 1983 and the Aid flow (current US$) in Korea in 1985?
Your answer should be compact. -5.46e+06. What is the difference between the Aid flow (current US$) of Belgium in 1983 and the Aid flow (current US$) of Denmark in 1985?
Your answer should be compact. -2.48e+06. What is the difference between the Aid flow (current US$) in Belgium in 1983 and the Aid flow (current US$) in Korea in 1985?
Offer a terse response. -3.27e+06. What is the difference between the Aid flow (current US$) of Denmark in 1983 and the Aid flow (current US$) of Korea in 1985?
Provide a short and direct response. -3.67e+06. What is the difference between the Aid flow (current US$) of Austria in 1983 and the Aid flow (current US$) of Belgium in 1986?
Provide a succinct answer. -4.33e+06. What is the difference between the Aid flow (current US$) of Austria in 1983 and the Aid flow (current US$) of Denmark in 1986?
Provide a succinct answer. -4.32e+06. What is the difference between the Aid flow (current US$) of Austria in 1983 and the Aid flow (current US$) of Korea in 1986?
Your response must be concise. -6.58e+06. What is the difference between the Aid flow (current US$) of Belgium in 1983 and the Aid flow (current US$) of Denmark in 1986?
Ensure brevity in your answer.  -2.13e+06. What is the difference between the Aid flow (current US$) in Belgium in 1983 and the Aid flow (current US$) in Korea in 1986?
Ensure brevity in your answer.  -4.39e+06. What is the difference between the Aid flow (current US$) in Denmark in 1983 and the Aid flow (current US$) in Korea in 1986?
Offer a very short reply. -4.79e+06. What is the difference between the Aid flow (current US$) of Austria in 1984 and the Aid flow (current US$) of Belgium in 1985?
Ensure brevity in your answer.  -2.72e+06. What is the difference between the Aid flow (current US$) in Austria in 1984 and the Aid flow (current US$) in Denmark in 1985?
Offer a terse response. -4.73e+06. What is the difference between the Aid flow (current US$) of Austria in 1984 and the Aid flow (current US$) of Korea in 1985?
Offer a very short reply. -5.52e+06. What is the difference between the Aid flow (current US$) in Belgium in 1984 and the Aid flow (current US$) in Denmark in 1985?
Your answer should be very brief. -2.81e+06. What is the difference between the Aid flow (current US$) in Belgium in 1984 and the Aid flow (current US$) in Korea in 1985?
Keep it short and to the point. -3.60e+06. What is the difference between the Aid flow (current US$) in Denmark in 1984 and the Aid flow (current US$) in Korea in 1985?
Your answer should be compact. -1.26e+06. What is the difference between the Aid flow (current US$) of Austria in 1984 and the Aid flow (current US$) of Belgium in 1986?
Offer a very short reply. -4.39e+06. What is the difference between the Aid flow (current US$) in Austria in 1984 and the Aid flow (current US$) in Denmark in 1986?
Your answer should be compact. -4.38e+06. What is the difference between the Aid flow (current US$) in Austria in 1984 and the Aid flow (current US$) in Korea in 1986?
Offer a very short reply. -6.64e+06. What is the difference between the Aid flow (current US$) in Belgium in 1984 and the Aid flow (current US$) in Denmark in 1986?
Make the answer very short. -2.46e+06. What is the difference between the Aid flow (current US$) of Belgium in 1984 and the Aid flow (current US$) of Korea in 1986?
Ensure brevity in your answer.  -4.72e+06. What is the difference between the Aid flow (current US$) in Denmark in 1984 and the Aid flow (current US$) in Korea in 1986?
Ensure brevity in your answer.  -2.38e+06. What is the difference between the Aid flow (current US$) in Austria in 1985 and the Aid flow (current US$) in Belgium in 1986?
Your answer should be very brief. -4.43e+06. What is the difference between the Aid flow (current US$) in Austria in 1985 and the Aid flow (current US$) in Denmark in 1986?
Make the answer very short. -4.42e+06. What is the difference between the Aid flow (current US$) in Austria in 1985 and the Aid flow (current US$) in Korea in 1986?
Offer a very short reply. -6.68e+06. What is the difference between the Aid flow (current US$) of Belgium in 1985 and the Aid flow (current US$) of Denmark in 1986?
Provide a succinct answer. -1.66e+06. What is the difference between the Aid flow (current US$) in Belgium in 1985 and the Aid flow (current US$) in Korea in 1986?
Your answer should be very brief. -3.92e+06. What is the difference between the Aid flow (current US$) in Denmark in 1985 and the Aid flow (current US$) in Korea in 1986?
Give a very brief answer. -1.91e+06. What is the average Aid flow (current US$) of Austria per year?
Give a very brief answer. 3.93e+05. What is the average Aid flow (current US$) in Belgium per year?
Your response must be concise. 2.69e+06. What is the average Aid flow (current US$) of Denmark per year?
Your answer should be very brief. 2.62e+06. What is the average Aid flow (current US$) of Korea per year?
Offer a terse response. 4.44e+06. In the year 1978, what is the difference between the Aid flow (current US$) in Austria and Aid flow (current US$) in Belgium?
Offer a very short reply. -2.97e+06. In the year 1978, what is the difference between the Aid flow (current US$) of Austria and Aid flow (current US$) of Denmark?
Your response must be concise. -2.20e+05. In the year 1978, what is the difference between the Aid flow (current US$) in Austria and Aid flow (current US$) in Korea?
Ensure brevity in your answer.  -3.75e+06. In the year 1978, what is the difference between the Aid flow (current US$) in Belgium and Aid flow (current US$) in Denmark?
Provide a succinct answer. 2.75e+06. In the year 1978, what is the difference between the Aid flow (current US$) of Belgium and Aid flow (current US$) of Korea?
Offer a very short reply. -7.80e+05. In the year 1978, what is the difference between the Aid flow (current US$) of Denmark and Aid flow (current US$) of Korea?
Offer a terse response. -3.53e+06. In the year 1979, what is the difference between the Aid flow (current US$) in Austria and Aid flow (current US$) in Belgium?
Offer a terse response. -1.52e+06. In the year 1979, what is the difference between the Aid flow (current US$) in Austria and Aid flow (current US$) in Denmark?
Keep it short and to the point. -9.10e+05. In the year 1979, what is the difference between the Aid flow (current US$) in Austria and Aid flow (current US$) in Korea?
Provide a short and direct response. -3.07e+06. In the year 1979, what is the difference between the Aid flow (current US$) of Belgium and Aid flow (current US$) of Korea?
Keep it short and to the point. -1.55e+06. In the year 1979, what is the difference between the Aid flow (current US$) of Denmark and Aid flow (current US$) of Korea?
Keep it short and to the point. -2.16e+06. In the year 1980, what is the difference between the Aid flow (current US$) in Austria and Aid flow (current US$) in Belgium?
Ensure brevity in your answer.  -2.37e+06. In the year 1980, what is the difference between the Aid flow (current US$) of Austria and Aid flow (current US$) of Denmark?
Keep it short and to the point. -1.90e+06. In the year 1980, what is the difference between the Aid flow (current US$) of Austria and Aid flow (current US$) of Korea?
Your answer should be very brief. -8.26e+06. In the year 1980, what is the difference between the Aid flow (current US$) of Belgium and Aid flow (current US$) of Denmark?
Offer a terse response. 4.70e+05. In the year 1980, what is the difference between the Aid flow (current US$) in Belgium and Aid flow (current US$) in Korea?
Ensure brevity in your answer.  -5.89e+06. In the year 1980, what is the difference between the Aid flow (current US$) in Denmark and Aid flow (current US$) in Korea?
Give a very brief answer. -6.36e+06. In the year 1981, what is the difference between the Aid flow (current US$) of Austria and Aid flow (current US$) of Belgium?
Offer a terse response. -1.19e+06. In the year 1981, what is the difference between the Aid flow (current US$) in Austria and Aid flow (current US$) in Denmark?
Your response must be concise. -9.70e+05. In the year 1981, what is the difference between the Aid flow (current US$) in Austria and Aid flow (current US$) in Korea?
Your answer should be compact. -4.79e+06. In the year 1981, what is the difference between the Aid flow (current US$) of Belgium and Aid flow (current US$) of Denmark?
Ensure brevity in your answer.  2.20e+05. In the year 1981, what is the difference between the Aid flow (current US$) in Belgium and Aid flow (current US$) in Korea?
Keep it short and to the point. -3.60e+06. In the year 1981, what is the difference between the Aid flow (current US$) in Denmark and Aid flow (current US$) in Korea?
Ensure brevity in your answer.  -3.82e+06. In the year 1982, what is the difference between the Aid flow (current US$) of Austria and Aid flow (current US$) of Belgium?
Your answer should be compact. -1.35e+06. In the year 1982, what is the difference between the Aid flow (current US$) in Austria and Aid flow (current US$) in Denmark?
Provide a short and direct response. -7.60e+05. In the year 1982, what is the difference between the Aid flow (current US$) in Austria and Aid flow (current US$) in Korea?
Your response must be concise. -1.64e+06. In the year 1982, what is the difference between the Aid flow (current US$) in Belgium and Aid flow (current US$) in Denmark?
Your answer should be compact. 5.90e+05. In the year 1982, what is the difference between the Aid flow (current US$) in Belgium and Aid flow (current US$) in Korea?
Your response must be concise. -2.90e+05. In the year 1982, what is the difference between the Aid flow (current US$) in Denmark and Aid flow (current US$) in Korea?
Provide a short and direct response. -8.80e+05. In the year 1983, what is the difference between the Aid flow (current US$) in Austria and Aid flow (current US$) in Belgium?
Keep it short and to the point. -2.19e+06. In the year 1983, what is the difference between the Aid flow (current US$) of Austria and Aid flow (current US$) of Denmark?
Keep it short and to the point. -1.79e+06. In the year 1983, what is the difference between the Aid flow (current US$) of Austria and Aid flow (current US$) of Korea?
Offer a terse response. -1.48e+06. In the year 1983, what is the difference between the Aid flow (current US$) of Belgium and Aid flow (current US$) of Korea?
Make the answer very short. 7.10e+05. In the year 1984, what is the difference between the Aid flow (current US$) of Austria and Aid flow (current US$) of Belgium?
Provide a succinct answer. -1.92e+06. In the year 1984, what is the difference between the Aid flow (current US$) of Austria and Aid flow (current US$) of Denmark?
Keep it short and to the point. -4.26e+06. In the year 1984, what is the difference between the Aid flow (current US$) of Austria and Aid flow (current US$) of Korea?
Offer a terse response. -1.23e+06. In the year 1984, what is the difference between the Aid flow (current US$) in Belgium and Aid flow (current US$) in Denmark?
Your answer should be very brief. -2.34e+06. In the year 1984, what is the difference between the Aid flow (current US$) of Belgium and Aid flow (current US$) of Korea?
Your answer should be very brief. 6.90e+05. In the year 1984, what is the difference between the Aid flow (current US$) in Denmark and Aid flow (current US$) in Korea?
Ensure brevity in your answer.  3.03e+06. In the year 1985, what is the difference between the Aid flow (current US$) in Austria and Aid flow (current US$) in Belgium?
Keep it short and to the point. -2.76e+06. In the year 1985, what is the difference between the Aid flow (current US$) in Austria and Aid flow (current US$) in Denmark?
Keep it short and to the point. -4.77e+06. In the year 1985, what is the difference between the Aid flow (current US$) in Austria and Aid flow (current US$) in Korea?
Offer a terse response. -5.56e+06. In the year 1985, what is the difference between the Aid flow (current US$) of Belgium and Aid flow (current US$) of Denmark?
Provide a succinct answer. -2.01e+06. In the year 1985, what is the difference between the Aid flow (current US$) of Belgium and Aid flow (current US$) of Korea?
Your answer should be very brief. -2.80e+06. In the year 1985, what is the difference between the Aid flow (current US$) in Denmark and Aid flow (current US$) in Korea?
Your response must be concise. -7.90e+05. In the year 1986, what is the difference between the Aid flow (current US$) in Austria and Aid flow (current US$) in Belgium?
Your response must be concise. -4.43e+06. In the year 1986, what is the difference between the Aid flow (current US$) in Austria and Aid flow (current US$) in Denmark?
Keep it short and to the point. -4.42e+06. In the year 1986, what is the difference between the Aid flow (current US$) of Austria and Aid flow (current US$) of Korea?
Make the answer very short. -6.68e+06. In the year 1986, what is the difference between the Aid flow (current US$) of Belgium and Aid flow (current US$) of Denmark?
Provide a short and direct response. 10000. In the year 1986, what is the difference between the Aid flow (current US$) of Belgium and Aid flow (current US$) of Korea?
Your response must be concise. -2.25e+06. In the year 1986, what is the difference between the Aid flow (current US$) in Denmark and Aid flow (current US$) in Korea?
Ensure brevity in your answer.  -2.26e+06. What is the ratio of the Aid flow (current US$) of Austria in 1978 to that in 1979?
Ensure brevity in your answer.  0.43. What is the ratio of the Aid flow (current US$) in Belgium in 1978 to that in 1979?
Keep it short and to the point. 1.21. What is the ratio of the Aid flow (current US$) of Denmark in 1978 to that in 1979?
Your response must be concise. 0.35. What is the ratio of the Aid flow (current US$) in Korea in 1978 to that in 1979?
Keep it short and to the point. 0.97. What is the ratio of the Aid flow (current US$) of Austria in 1978 to that in 1980?
Your response must be concise. 1.52. What is the ratio of the Aid flow (current US$) in Belgium in 1978 to that in 1980?
Your response must be concise. 1.29. What is the ratio of the Aid flow (current US$) of Denmark in 1978 to that in 1980?
Your answer should be very brief. 0.36. What is the ratio of the Aid flow (current US$) of Korea in 1978 to that in 1980?
Provide a short and direct response. 0.5. What is the ratio of the Aid flow (current US$) in Austria in 1978 to that in 1981?
Your answer should be very brief. 1.39. What is the ratio of the Aid flow (current US$) of Belgium in 1978 to that in 1981?
Offer a terse response. 2.2. What is the ratio of the Aid flow (current US$) of Denmark in 1978 to that in 1981?
Provide a succinct answer. 0.59. What is the ratio of the Aid flow (current US$) in Korea in 1978 to that in 1981?
Give a very brief answer. 0.83. What is the ratio of the Aid flow (current US$) of Austria in 1978 to that in 1982?
Give a very brief answer. 3.05. What is the ratio of the Aid flow (current US$) of Belgium in 1978 to that in 1982?
Your response must be concise. 2.31. What is the ratio of the Aid flow (current US$) of Denmark in 1978 to that in 1982?
Provide a succinct answer. 0.86. What is the ratio of the Aid flow (current US$) of Korea in 1978 to that in 1982?
Your answer should be very brief. 2.37. What is the ratio of the Aid flow (current US$) of Austria in 1978 to that in 1983?
Your response must be concise. 3.39. What is the ratio of the Aid flow (current US$) in Belgium in 1978 to that in 1983?
Provide a short and direct response. 1.51. What is the ratio of the Aid flow (current US$) in Denmark in 1978 to that in 1983?
Give a very brief answer. 0.42. What is the ratio of the Aid flow (current US$) of Korea in 1978 to that in 1983?
Provide a short and direct response. 2.63. What is the ratio of the Aid flow (current US$) of Austria in 1978 to that in 1984?
Your response must be concise. 5.08. What is the ratio of the Aid flow (current US$) in Belgium in 1978 to that in 1984?
Your response must be concise. 1.75. What is the ratio of the Aid flow (current US$) of Denmark in 1978 to that in 1984?
Offer a very short reply. 0.19. What is the ratio of the Aid flow (current US$) in Korea in 1978 to that in 1984?
Give a very brief answer. 3.23. What is the ratio of the Aid flow (current US$) in Austria in 1978 to that in 1985?
Offer a very short reply. 7.62. What is the ratio of the Aid flow (current US$) in Belgium in 1978 to that in 1985?
Give a very brief answer. 1.26. What is the ratio of the Aid flow (current US$) of Denmark in 1978 to that in 1985?
Provide a short and direct response. 0.17. What is the ratio of the Aid flow (current US$) of Korea in 1978 to that in 1985?
Your response must be concise. 0.77. What is the ratio of the Aid flow (current US$) in Austria in 1978 to that in 1986?
Your response must be concise. 7.62. What is the ratio of the Aid flow (current US$) of Belgium in 1978 to that in 1986?
Ensure brevity in your answer.  0.79. What is the ratio of the Aid flow (current US$) in Denmark in 1978 to that in 1986?
Provide a succinct answer. 0.18. What is the ratio of the Aid flow (current US$) of Korea in 1978 to that in 1986?
Provide a short and direct response. 0.65. What is the ratio of the Aid flow (current US$) of Austria in 1979 to that in 1980?
Offer a very short reply. 3.58. What is the ratio of the Aid flow (current US$) in Belgium in 1979 to that in 1980?
Offer a terse response. 1.06. What is the ratio of the Aid flow (current US$) in Denmark in 1979 to that in 1980?
Your answer should be very brief. 1.02. What is the ratio of the Aid flow (current US$) of Korea in 1979 to that in 1980?
Give a very brief answer. 0.52. What is the ratio of the Aid flow (current US$) of Belgium in 1979 to that in 1981?
Keep it short and to the point. 1.81. What is the ratio of the Aid flow (current US$) of Denmark in 1979 to that in 1981?
Provide a succinct answer. 1.66. What is the ratio of the Aid flow (current US$) in Korea in 1979 to that in 1981?
Make the answer very short. 0.86. What is the ratio of the Aid flow (current US$) of Austria in 1979 to that in 1982?
Provide a succinct answer. 7.15. What is the ratio of the Aid flow (current US$) in Belgium in 1979 to that in 1982?
Ensure brevity in your answer.  1.9. What is the ratio of the Aid flow (current US$) in Denmark in 1979 to that in 1982?
Your response must be concise. 2.44. What is the ratio of the Aid flow (current US$) in Korea in 1979 to that in 1982?
Your response must be concise. 2.45. What is the ratio of the Aid flow (current US$) in Austria in 1979 to that in 1983?
Offer a terse response. 7.94. What is the ratio of the Aid flow (current US$) in Belgium in 1979 to that in 1983?
Offer a terse response. 1.24. What is the ratio of the Aid flow (current US$) in Denmark in 1979 to that in 1983?
Offer a terse response. 1.19. What is the ratio of the Aid flow (current US$) in Korea in 1979 to that in 1983?
Give a very brief answer. 2.71. What is the ratio of the Aid flow (current US$) in Austria in 1979 to that in 1984?
Ensure brevity in your answer.  11.92. What is the ratio of the Aid flow (current US$) of Belgium in 1979 to that in 1984?
Provide a succinct answer. 1.45. What is the ratio of the Aid flow (current US$) of Denmark in 1979 to that in 1984?
Offer a terse response. 0.53. What is the ratio of the Aid flow (current US$) in Austria in 1979 to that in 1985?
Your answer should be compact. 17.88. What is the ratio of the Aid flow (current US$) in Belgium in 1979 to that in 1985?
Your answer should be compact. 1.04. What is the ratio of the Aid flow (current US$) in Denmark in 1979 to that in 1985?
Ensure brevity in your answer.  0.48. What is the ratio of the Aid flow (current US$) of Korea in 1979 to that in 1985?
Your answer should be compact. 0.8. What is the ratio of the Aid flow (current US$) in Austria in 1979 to that in 1986?
Provide a short and direct response. 17.88. What is the ratio of the Aid flow (current US$) in Belgium in 1979 to that in 1986?
Your answer should be compact. 0.65. What is the ratio of the Aid flow (current US$) in Denmark in 1979 to that in 1986?
Offer a terse response. 0.52. What is the ratio of the Aid flow (current US$) of Korea in 1979 to that in 1986?
Keep it short and to the point. 0.67. What is the ratio of the Aid flow (current US$) of Belgium in 1980 to that in 1981?
Your answer should be very brief. 1.7. What is the ratio of the Aid flow (current US$) of Denmark in 1980 to that in 1981?
Offer a terse response. 1.63. What is the ratio of the Aid flow (current US$) in Korea in 1980 to that in 1981?
Offer a terse response. 1.66. What is the ratio of the Aid flow (current US$) in Austria in 1980 to that in 1982?
Give a very brief answer. 2. What is the ratio of the Aid flow (current US$) in Belgium in 1980 to that in 1982?
Keep it short and to the point. 1.79. What is the ratio of the Aid flow (current US$) of Denmark in 1980 to that in 1982?
Offer a terse response. 2.4. What is the ratio of the Aid flow (current US$) in Korea in 1980 to that in 1982?
Offer a very short reply. 4.71. What is the ratio of the Aid flow (current US$) in Austria in 1980 to that in 1983?
Keep it short and to the point. 2.22. What is the ratio of the Aid flow (current US$) of Belgium in 1980 to that in 1983?
Provide a short and direct response. 1.17. What is the ratio of the Aid flow (current US$) of Denmark in 1980 to that in 1983?
Your answer should be very brief. 1.17. What is the ratio of the Aid flow (current US$) of Korea in 1980 to that in 1983?
Give a very brief answer. 5.22. What is the ratio of the Aid flow (current US$) of Austria in 1980 to that in 1984?
Your answer should be compact. 3.33. What is the ratio of the Aid flow (current US$) in Belgium in 1980 to that in 1984?
Offer a terse response. 1.36. What is the ratio of the Aid flow (current US$) of Denmark in 1980 to that in 1984?
Your response must be concise. 0.53. What is the ratio of the Aid flow (current US$) of Korea in 1980 to that in 1984?
Offer a terse response. 6.41. What is the ratio of the Aid flow (current US$) in Austria in 1980 to that in 1985?
Give a very brief answer. 5. What is the ratio of the Aid flow (current US$) in Belgium in 1980 to that in 1985?
Provide a succinct answer. 0.98. What is the ratio of the Aid flow (current US$) of Denmark in 1980 to that in 1985?
Make the answer very short. 0.47. What is the ratio of the Aid flow (current US$) in Korea in 1980 to that in 1985?
Offer a terse response. 1.54. What is the ratio of the Aid flow (current US$) of Austria in 1980 to that in 1986?
Your answer should be very brief. 5. What is the ratio of the Aid flow (current US$) of Belgium in 1980 to that in 1986?
Your response must be concise. 0.61. What is the ratio of the Aid flow (current US$) of Denmark in 1980 to that in 1986?
Keep it short and to the point. 0.51. What is the ratio of the Aid flow (current US$) of Korea in 1980 to that in 1986?
Ensure brevity in your answer.  1.28. What is the ratio of the Aid flow (current US$) of Belgium in 1981 to that in 1982?
Make the answer very short. 1.05. What is the ratio of the Aid flow (current US$) of Denmark in 1981 to that in 1982?
Provide a short and direct response. 1.47. What is the ratio of the Aid flow (current US$) of Korea in 1981 to that in 1982?
Ensure brevity in your answer.  2.84. What is the ratio of the Aid flow (current US$) in Austria in 1981 to that in 1983?
Provide a short and direct response. 2.44. What is the ratio of the Aid flow (current US$) in Belgium in 1981 to that in 1983?
Provide a succinct answer. 0.69. What is the ratio of the Aid flow (current US$) in Denmark in 1981 to that in 1983?
Give a very brief answer. 0.72. What is the ratio of the Aid flow (current US$) of Korea in 1981 to that in 1983?
Give a very brief answer. 3.15. What is the ratio of the Aid flow (current US$) of Austria in 1981 to that in 1984?
Ensure brevity in your answer.  3.67. What is the ratio of the Aid flow (current US$) of Belgium in 1981 to that in 1984?
Keep it short and to the point. 0.8. What is the ratio of the Aid flow (current US$) in Denmark in 1981 to that in 1984?
Your response must be concise. 0.32. What is the ratio of the Aid flow (current US$) of Korea in 1981 to that in 1984?
Keep it short and to the point. 3.87. What is the ratio of the Aid flow (current US$) of Belgium in 1981 to that in 1985?
Make the answer very short. 0.57. What is the ratio of the Aid flow (current US$) in Denmark in 1981 to that in 1985?
Keep it short and to the point. 0.29. What is the ratio of the Aid flow (current US$) in Korea in 1981 to that in 1985?
Provide a short and direct response. 0.93. What is the ratio of the Aid flow (current US$) in Belgium in 1981 to that in 1986?
Offer a terse response. 0.36. What is the ratio of the Aid flow (current US$) of Denmark in 1981 to that in 1986?
Ensure brevity in your answer.  0.31. What is the ratio of the Aid flow (current US$) of Korea in 1981 to that in 1986?
Ensure brevity in your answer.  0.77. What is the ratio of the Aid flow (current US$) of Austria in 1982 to that in 1983?
Give a very brief answer. 1.11. What is the ratio of the Aid flow (current US$) of Belgium in 1982 to that in 1983?
Your answer should be compact. 0.65. What is the ratio of the Aid flow (current US$) in Denmark in 1982 to that in 1983?
Your answer should be very brief. 0.49. What is the ratio of the Aid flow (current US$) of Korea in 1982 to that in 1983?
Offer a very short reply. 1.11. What is the ratio of the Aid flow (current US$) of Austria in 1982 to that in 1984?
Give a very brief answer. 1.67. What is the ratio of the Aid flow (current US$) in Belgium in 1982 to that in 1984?
Provide a succinct answer. 0.76. What is the ratio of the Aid flow (current US$) of Denmark in 1982 to that in 1984?
Your answer should be very brief. 0.22. What is the ratio of the Aid flow (current US$) of Korea in 1982 to that in 1984?
Ensure brevity in your answer.  1.36. What is the ratio of the Aid flow (current US$) of Belgium in 1982 to that in 1985?
Your answer should be very brief. 0.55. What is the ratio of the Aid flow (current US$) of Denmark in 1982 to that in 1985?
Your answer should be compact. 0.2. What is the ratio of the Aid flow (current US$) of Korea in 1982 to that in 1985?
Offer a terse response. 0.33. What is the ratio of the Aid flow (current US$) of Austria in 1982 to that in 1986?
Provide a succinct answer. 2.5. What is the ratio of the Aid flow (current US$) in Belgium in 1982 to that in 1986?
Your answer should be very brief. 0.34. What is the ratio of the Aid flow (current US$) of Denmark in 1982 to that in 1986?
Provide a short and direct response. 0.21. What is the ratio of the Aid flow (current US$) of Korea in 1982 to that in 1986?
Ensure brevity in your answer.  0.27. What is the ratio of the Aid flow (current US$) in Belgium in 1983 to that in 1984?
Make the answer very short. 1.16. What is the ratio of the Aid flow (current US$) of Denmark in 1983 to that in 1984?
Make the answer very short. 0.45. What is the ratio of the Aid flow (current US$) in Korea in 1983 to that in 1984?
Provide a short and direct response. 1.23. What is the ratio of the Aid flow (current US$) of Austria in 1983 to that in 1985?
Make the answer very short. 2.25. What is the ratio of the Aid flow (current US$) of Belgium in 1983 to that in 1985?
Offer a very short reply. 0.83. What is the ratio of the Aid flow (current US$) of Denmark in 1983 to that in 1985?
Provide a short and direct response. 0.41. What is the ratio of the Aid flow (current US$) of Korea in 1983 to that in 1985?
Provide a succinct answer. 0.29. What is the ratio of the Aid flow (current US$) of Austria in 1983 to that in 1986?
Your response must be concise. 2.25. What is the ratio of the Aid flow (current US$) of Belgium in 1983 to that in 1986?
Your response must be concise. 0.53. What is the ratio of the Aid flow (current US$) in Denmark in 1983 to that in 1986?
Keep it short and to the point. 0.44. What is the ratio of the Aid flow (current US$) in Korea in 1983 to that in 1986?
Offer a very short reply. 0.25. What is the ratio of the Aid flow (current US$) in Austria in 1984 to that in 1985?
Offer a very short reply. 1.5. What is the ratio of the Aid flow (current US$) in Belgium in 1984 to that in 1985?
Your response must be concise. 0.72. What is the ratio of the Aid flow (current US$) in Denmark in 1984 to that in 1985?
Give a very brief answer. 0.9. What is the ratio of the Aid flow (current US$) in Korea in 1984 to that in 1985?
Provide a succinct answer. 0.24. What is the ratio of the Aid flow (current US$) of Belgium in 1984 to that in 1986?
Make the answer very short. 0.45. What is the ratio of the Aid flow (current US$) of Denmark in 1984 to that in 1986?
Keep it short and to the point. 0.97. What is the ratio of the Aid flow (current US$) in Korea in 1984 to that in 1986?
Provide a succinct answer. 0.2. What is the ratio of the Aid flow (current US$) of Belgium in 1985 to that in 1986?
Offer a terse response. 0.63. What is the ratio of the Aid flow (current US$) of Denmark in 1985 to that in 1986?
Ensure brevity in your answer.  1.08. What is the ratio of the Aid flow (current US$) of Korea in 1985 to that in 1986?
Offer a terse response. 0.83. What is the difference between the highest and the second highest Aid flow (current US$) of Austria?
Make the answer very short. 8.20e+05. What is the difference between the highest and the second highest Aid flow (current US$) of Belgium?
Give a very brief answer. 9.30e+05. What is the difference between the highest and the second highest Aid flow (current US$) of Korea?
Offer a terse response. 1.90e+06. What is the difference between the highest and the lowest Aid flow (current US$) in Austria?
Your answer should be compact. 1.35e+06. What is the difference between the highest and the lowest Aid flow (current US$) of Belgium?
Keep it short and to the point. 2.96e+06. What is the difference between the highest and the lowest Aid flow (current US$) in Denmark?
Your answer should be very brief. 4.02e+06. What is the difference between the highest and the lowest Aid flow (current US$) in Korea?
Keep it short and to the point. 7.31e+06. 